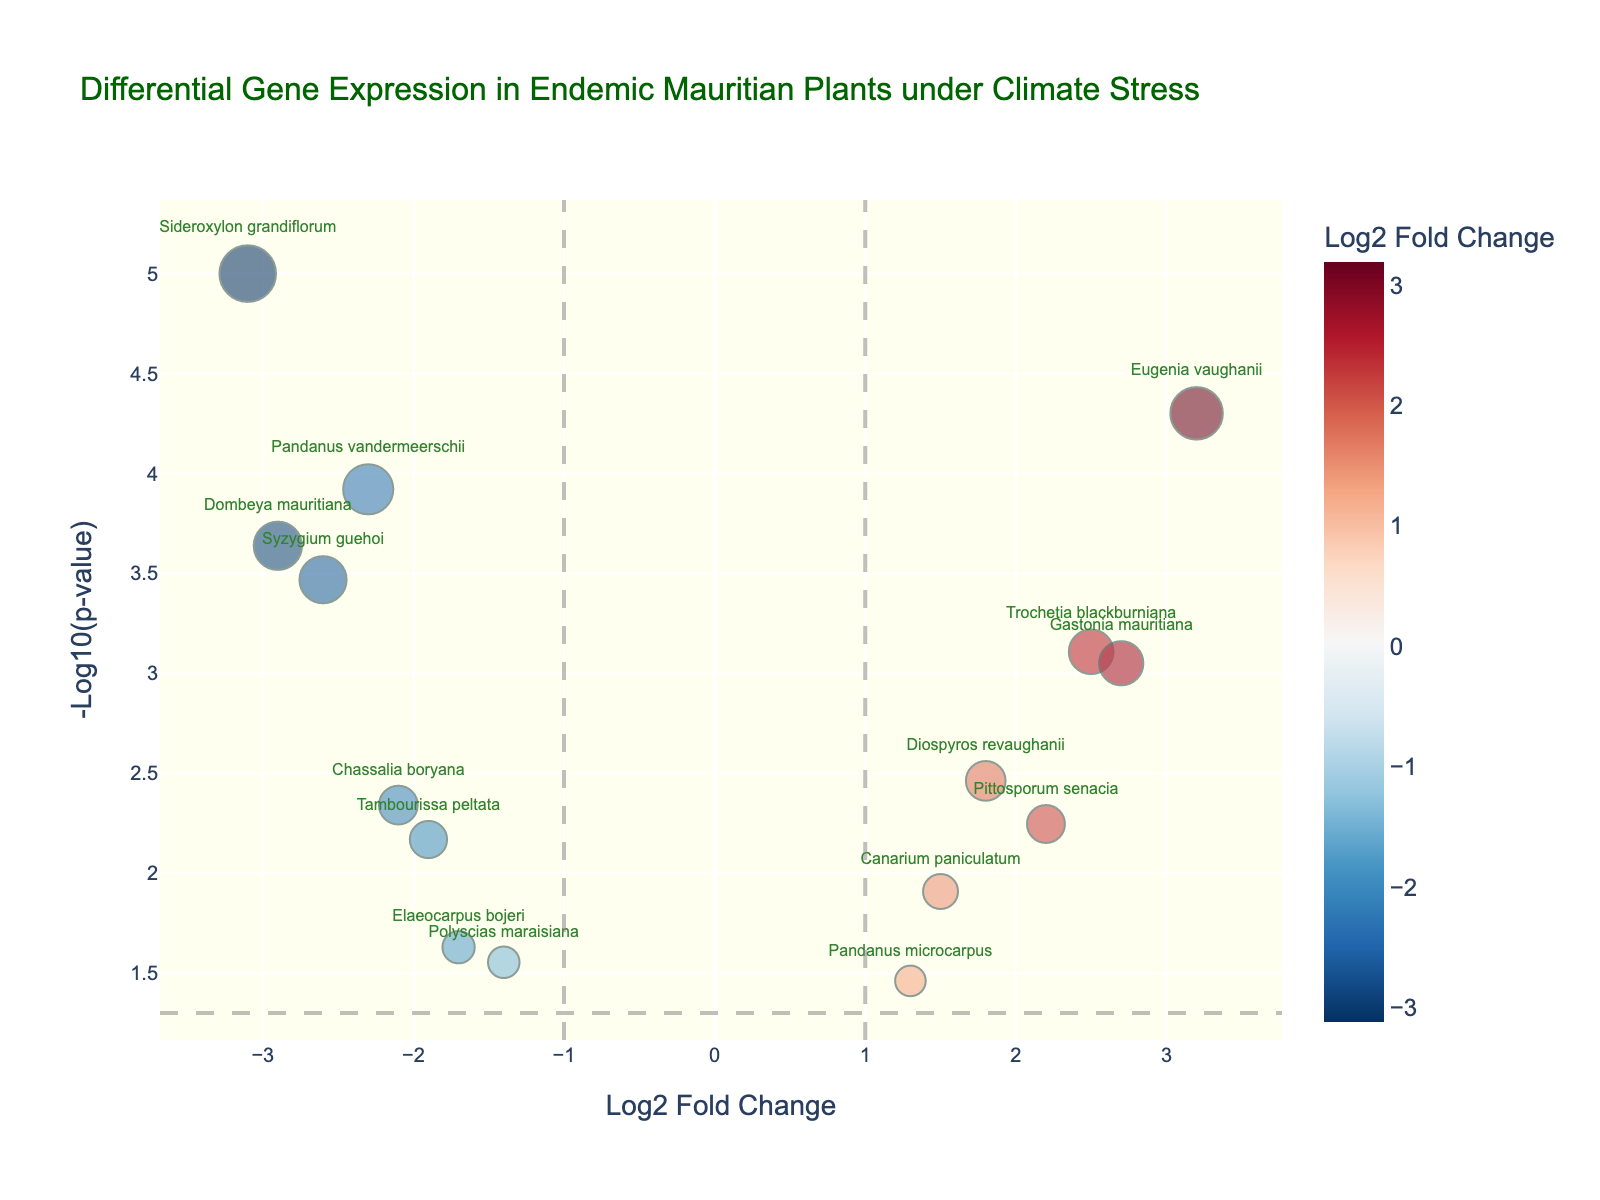What is the title of the plot? The title is typically positioned at the top of the figure. In this case, it reads 'Differential Gene Expression in Endemic Mauritian Plants under Climate Stress'. This text clearly indicates the context and focus of the data visualized.
Answer: Differential Gene Expression in Endemic Mauritian Plants under Climate Stress What do the axes represent? The x-axis and y-axis usually have labels indicating what they represent. Here, the x-axis represents 'Log2 Fold Change', and the y-axis represents '-Log10(p-value)'. The x-axis indicates the extent of gene expression changes, while the y-axis shows the significance of these changes.
Answer: The x-axis represents 'Log2 Fold Change' and the y-axis represents '-Log10(p-value)' How many genes have a positive Log2 Fold Change value? To find this information, count the points to the right of the y-axis where Log2 Fold Change is greater than zero. From the data, there are 6 genes plotted to the right.
Answer: 6 Which gene has the smallest p-value? The smallest p-value corresponds to the highest value on the y-axis. By identifying the topmost point, we can see it's 'Sideroxylon grandiflorum' with the highest -Log10(p-value) value.
Answer: Sideroxylon grandiflorum Which gene has the highest positive Log2 Fold Change? Scan the figure for the rightmost point, indicating the largest positive Log2 Fold Change. 'Eugenia vaughanii' is positioned farthest to the right.
Answer: Eugenia vaughanii Which gene has the highest negative Log2 Fold Change? Look at the leftmost point, which indicates the largest negative Log2 Fold Change. The gene 'Sideroxylon grandiflorum' is positioned farthest to the left.
Answer: Sideroxylon grandiflorum How many genes have a p-value less than 0.05? The plot has a horizontal threshold line at -Log10(0.05). Count the points above this line for the number of genes meeting this criterion.
Answer: 11 Which gene is closest to the vertical line with x=1? Identify the gene closest to the vertical threshold line at x=1. 'Gastonia mauritiana' appears nearest to this line.
Answer: Gastonia mauritiana Which gene is the farthest from both Log2 Fold Change thresholds of -1 and 1? To determine this, find the genes individually farthest left and right of these thresholds. 'Sideroxylon grandiflorum' is farthest to the left, and 'Eugenia vaughanii' is farthest to the right.
Answer: 'Sideroxylon grandiflorum' and 'Eugenia vaughanii' How does the significance of 'Pandanus vandermeerschii' compare to 'Pandanus microcarpus'? Compare their y-axis values. 'Pandanus vandermeerschii' is higher on the y-axis (-Log10(p-value)), indicating it's more significant.
Answer: 'Pandanus vandermeerschii' is more significant Which genes fall within the range of -2 to 2 for Log2 Fold Change and have a p-value less than 0.05? Count the points falling within -2 to 2 on the x-axis and above the p-value threshold line on the y-axis. These are 'Diospyros revaughanii', 'Pandanus vandermeerschii', 'Gastonia mauritiana', 'Syzygium guehoi', and 'Pittosporum senacia'.
Answer: 'Diospyros revaughanii', 'Pandanus vandermeerschii', 'Gastonia mauritiana', 'Syzygium guehoi', 'Pittosporum senacia' 